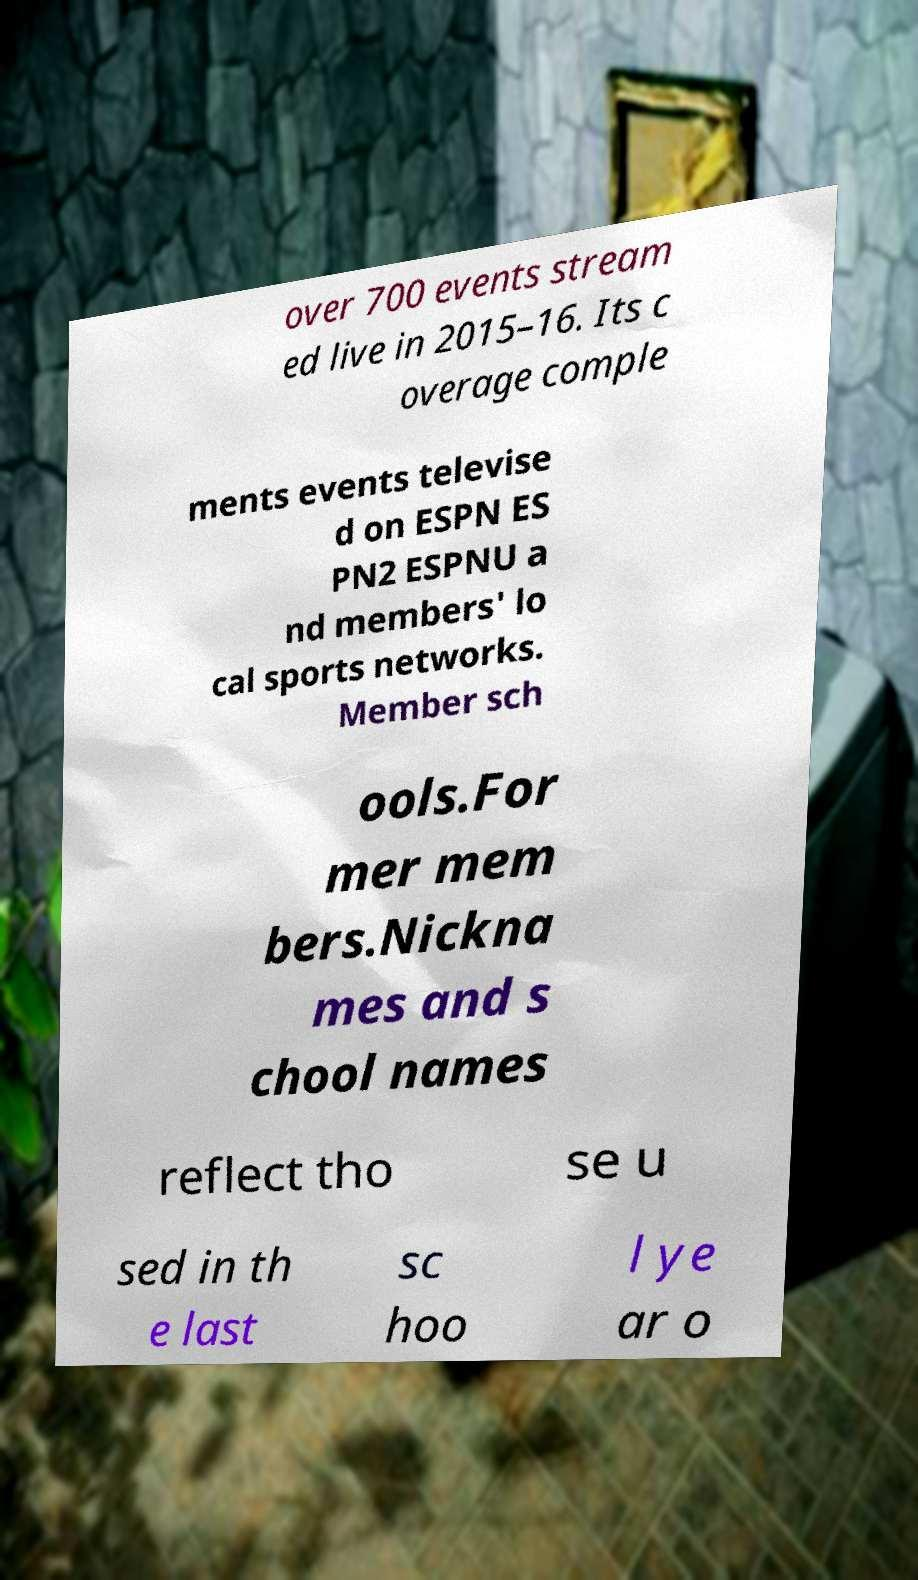For documentation purposes, I need the text within this image transcribed. Could you provide that? over 700 events stream ed live in 2015–16. Its c overage comple ments events televise d on ESPN ES PN2 ESPNU a nd members' lo cal sports networks. Member sch ools.For mer mem bers.Nickna mes and s chool names reflect tho se u sed in th e last sc hoo l ye ar o 